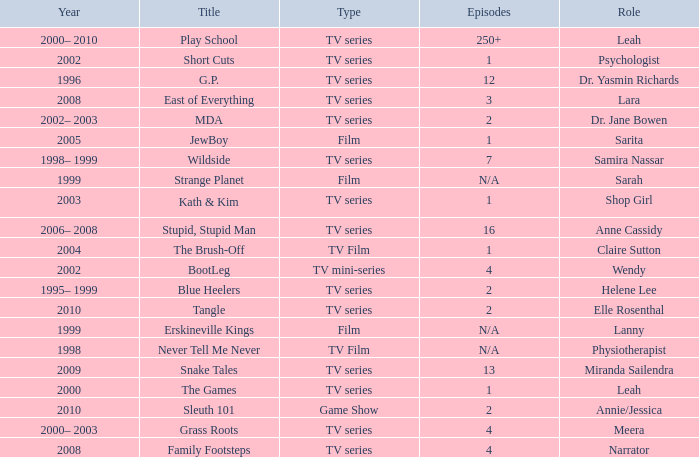What episode is called jewboy 1.0. 